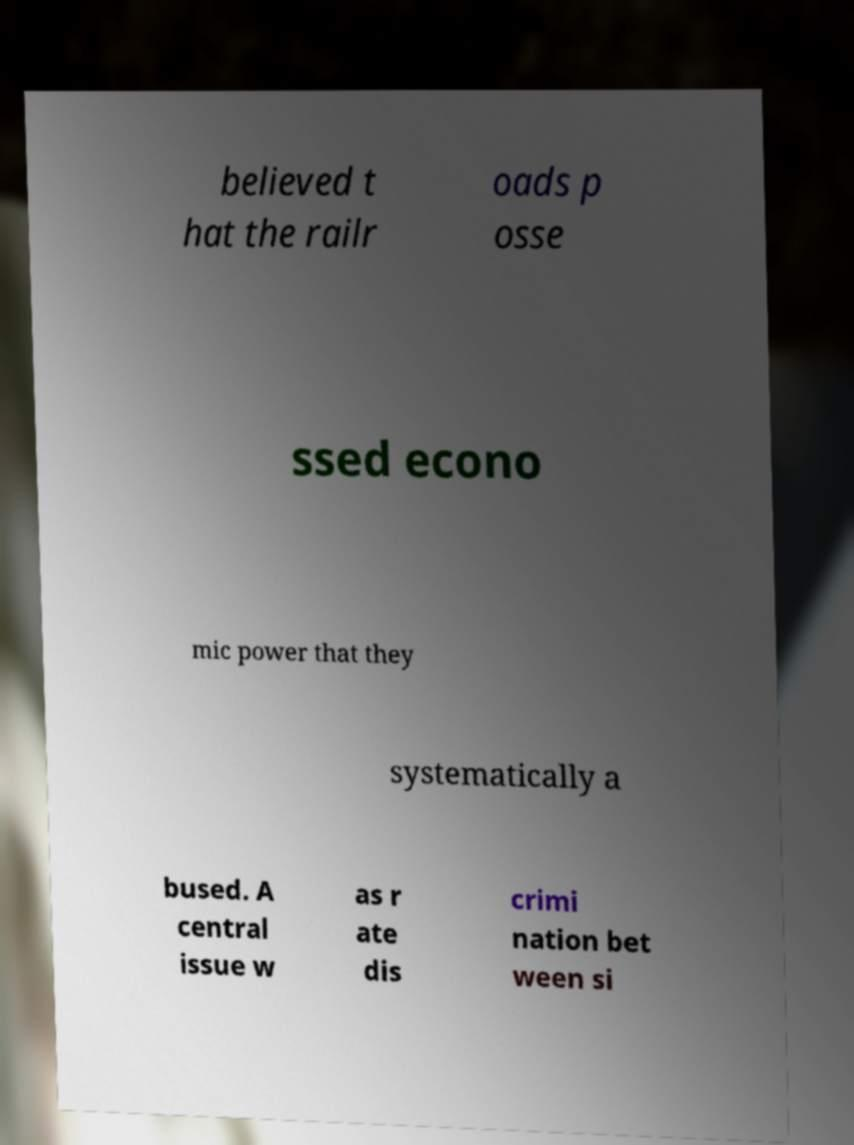Could you extract and type out the text from this image? believed t hat the railr oads p osse ssed econo mic power that they systematically a bused. A central issue w as r ate dis crimi nation bet ween si 